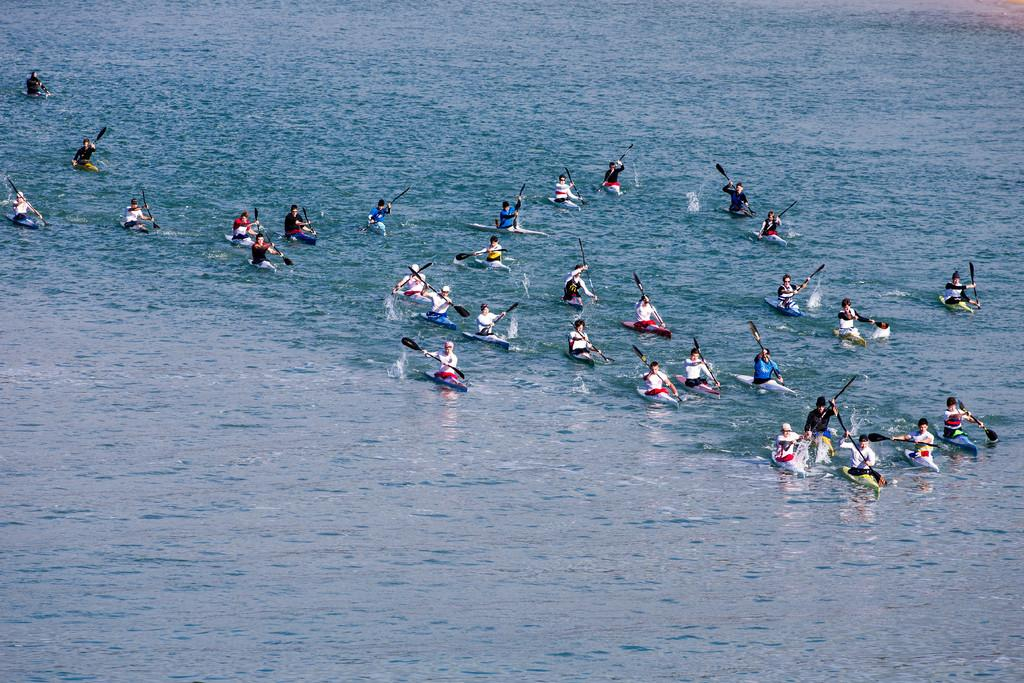What are the people in the image doing? The people in the image are sitting in kayak boats. Where are the kayak boats located? The kayak boats are on the water. What are the people holding in their hands? The people are holding paddles. What action are the people performing with their paddles? The people are rowing their boats. What type of insurance policy do the people in the image have for their kayaks? There is no information about insurance policies in the image, as it focuses on the people and their activity in the kayaks. 